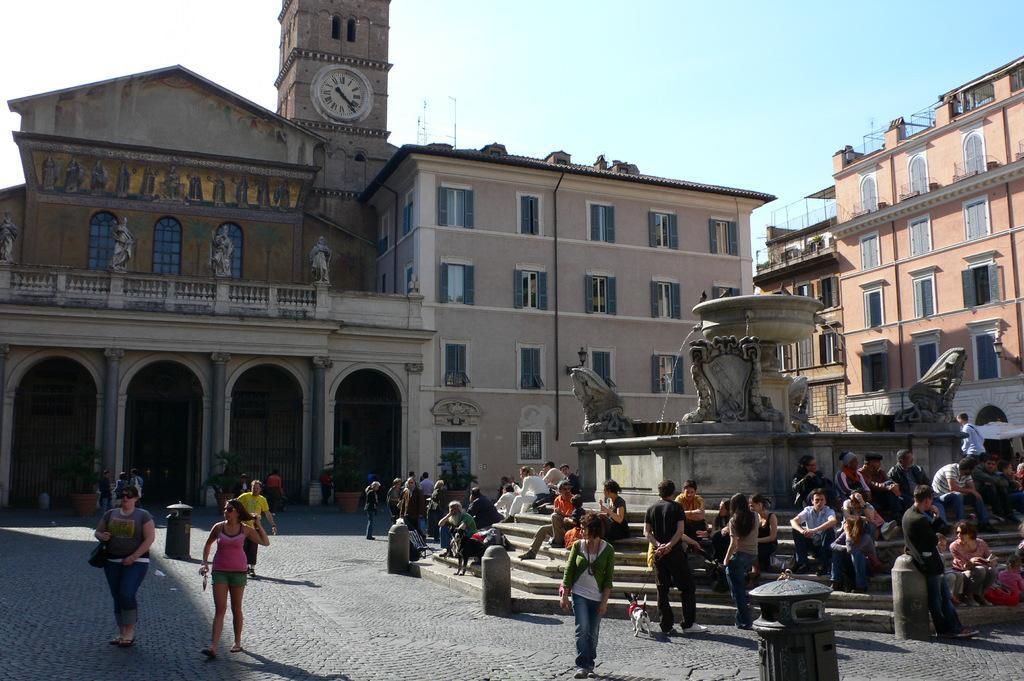Describe this image in one or two sentences. In this picture we can see the sky, poles, buildings, windows, a clock on the wall, few statues. We can see the plants, pots. We can see the people. Among them few people are sitting, standing and walking. We can see the stairs, water fountain, stone carvings. We can see a man is holding the belt of a dog. At the bottom portion of the picture we can see the floor and an object. 